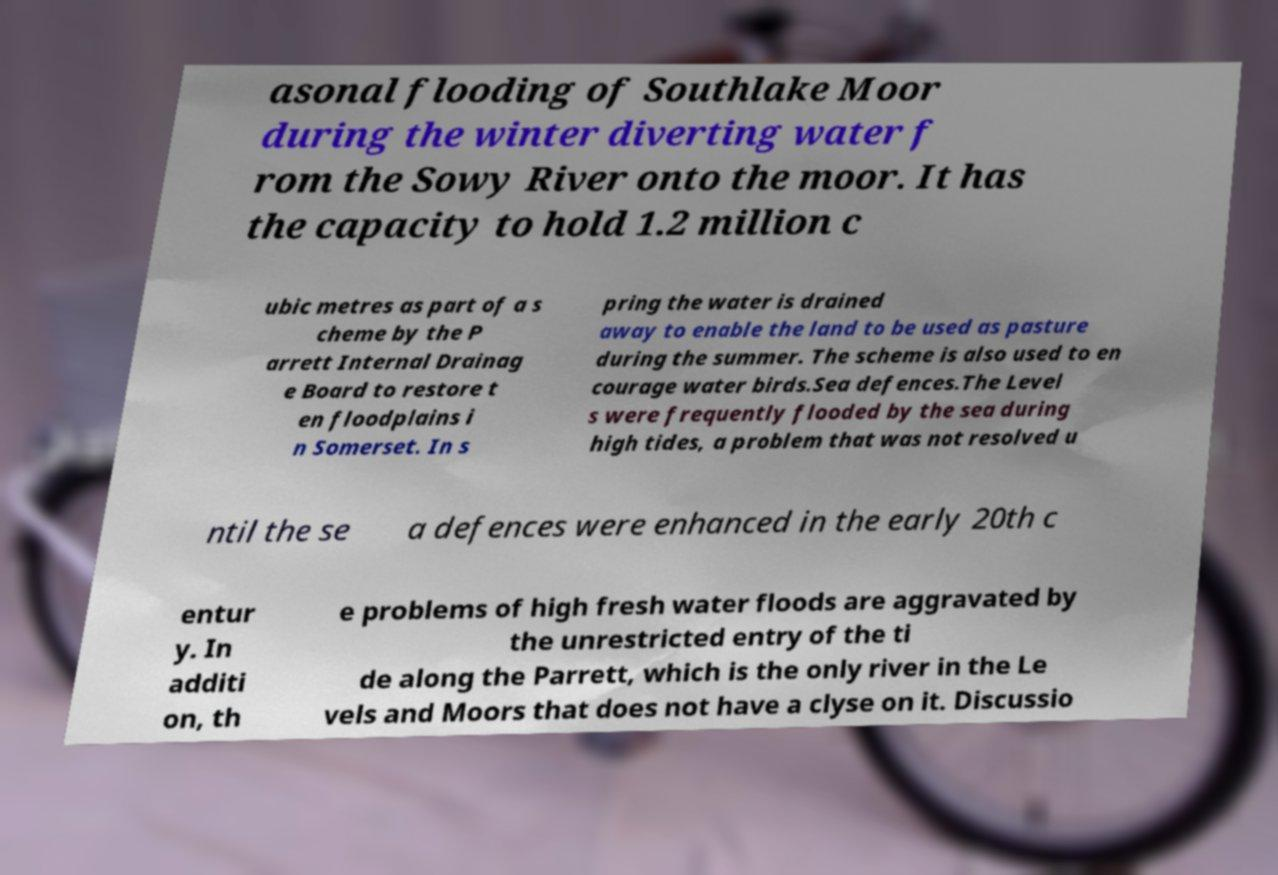Could you extract and type out the text from this image? asonal flooding of Southlake Moor during the winter diverting water f rom the Sowy River onto the moor. It has the capacity to hold 1.2 million c ubic metres as part of a s cheme by the P arrett Internal Drainag e Board to restore t en floodplains i n Somerset. In s pring the water is drained away to enable the land to be used as pasture during the summer. The scheme is also used to en courage water birds.Sea defences.The Level s were frequently flooded by the sea during high tides, a problem that was not resolved u ntil the se a defences were enhanced in the early 20th c entur y. In additi on, th e problems of high fresh water floods are aggravated by the unrestricted entry of the ti de along the Parrett, which is the only river in the Le vels and Moors that does not have a clyse on it. Discussio 